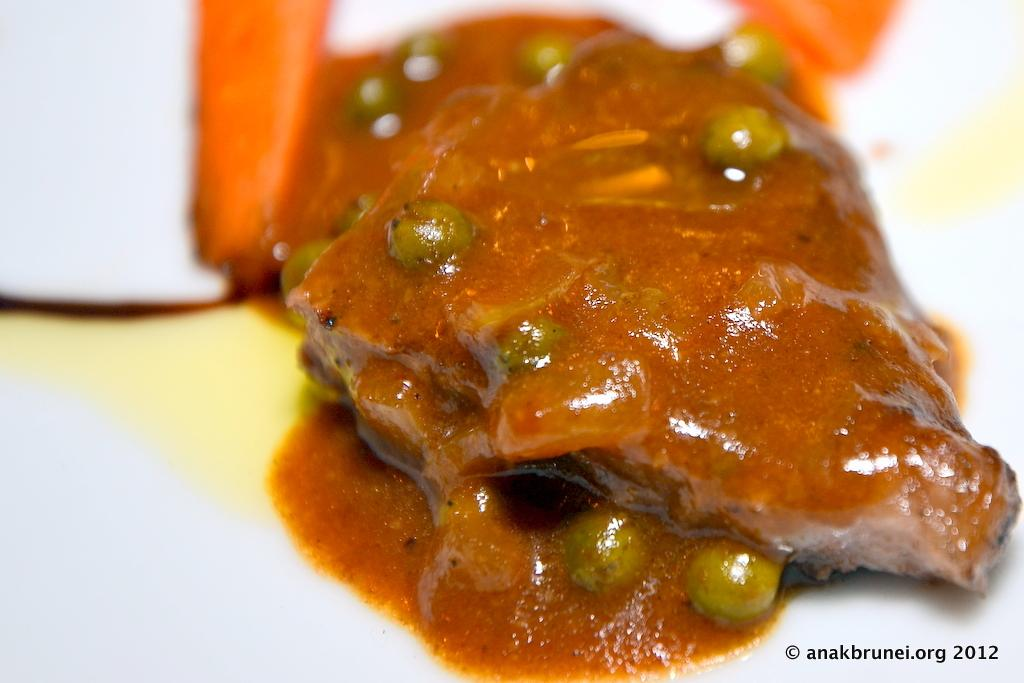What can be seen on the plate in the image? There are food items on a plate in the image. Is there any text present in the image? Yes, there is some text at the bottom of the image. How many brothers are sitting at the desk in the image? There is no desk or brothers present in the image. What type of beam is holding up the ceiling in the image? There is no beam or ceiling present in the image. 